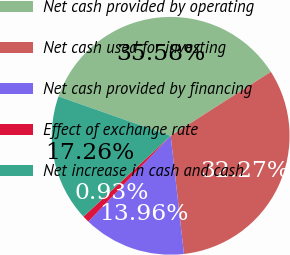<chart> <loc_0><loc_0><loc_500><loc_500><pie_chart><fcel>Net cash provided by operating<fcel>Net cash used for investing<fcel>Net cash provided by financing<fcel>Effect of exchange rate<fcel>Net increase in cash and cash<nl><fcel>35.58%<fcel>32.27%<fcel>13.96%<fcel>0.93%<fcel>17.26%<nl></chart> 